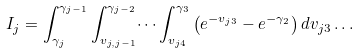Convert formula to latex. <formula><loc_0><loc_0><loc_500><loc_500>I _ { j } = \int _ { \gamma _ { j } } ^ { \gamma _ { j - 1 } } \int _ { v _ { j , j - 1 } } ^ { \gamma _ { j - 2 } } \dots \int _ { v _ { j 4 } } ^ { \gamma _ { 3 } } \left ( e ^ { - v _ { j 3 } } - e ^ { - \gamma _ { 2 } } \right ) d v _ { j 3 } \dots & &</formula> 